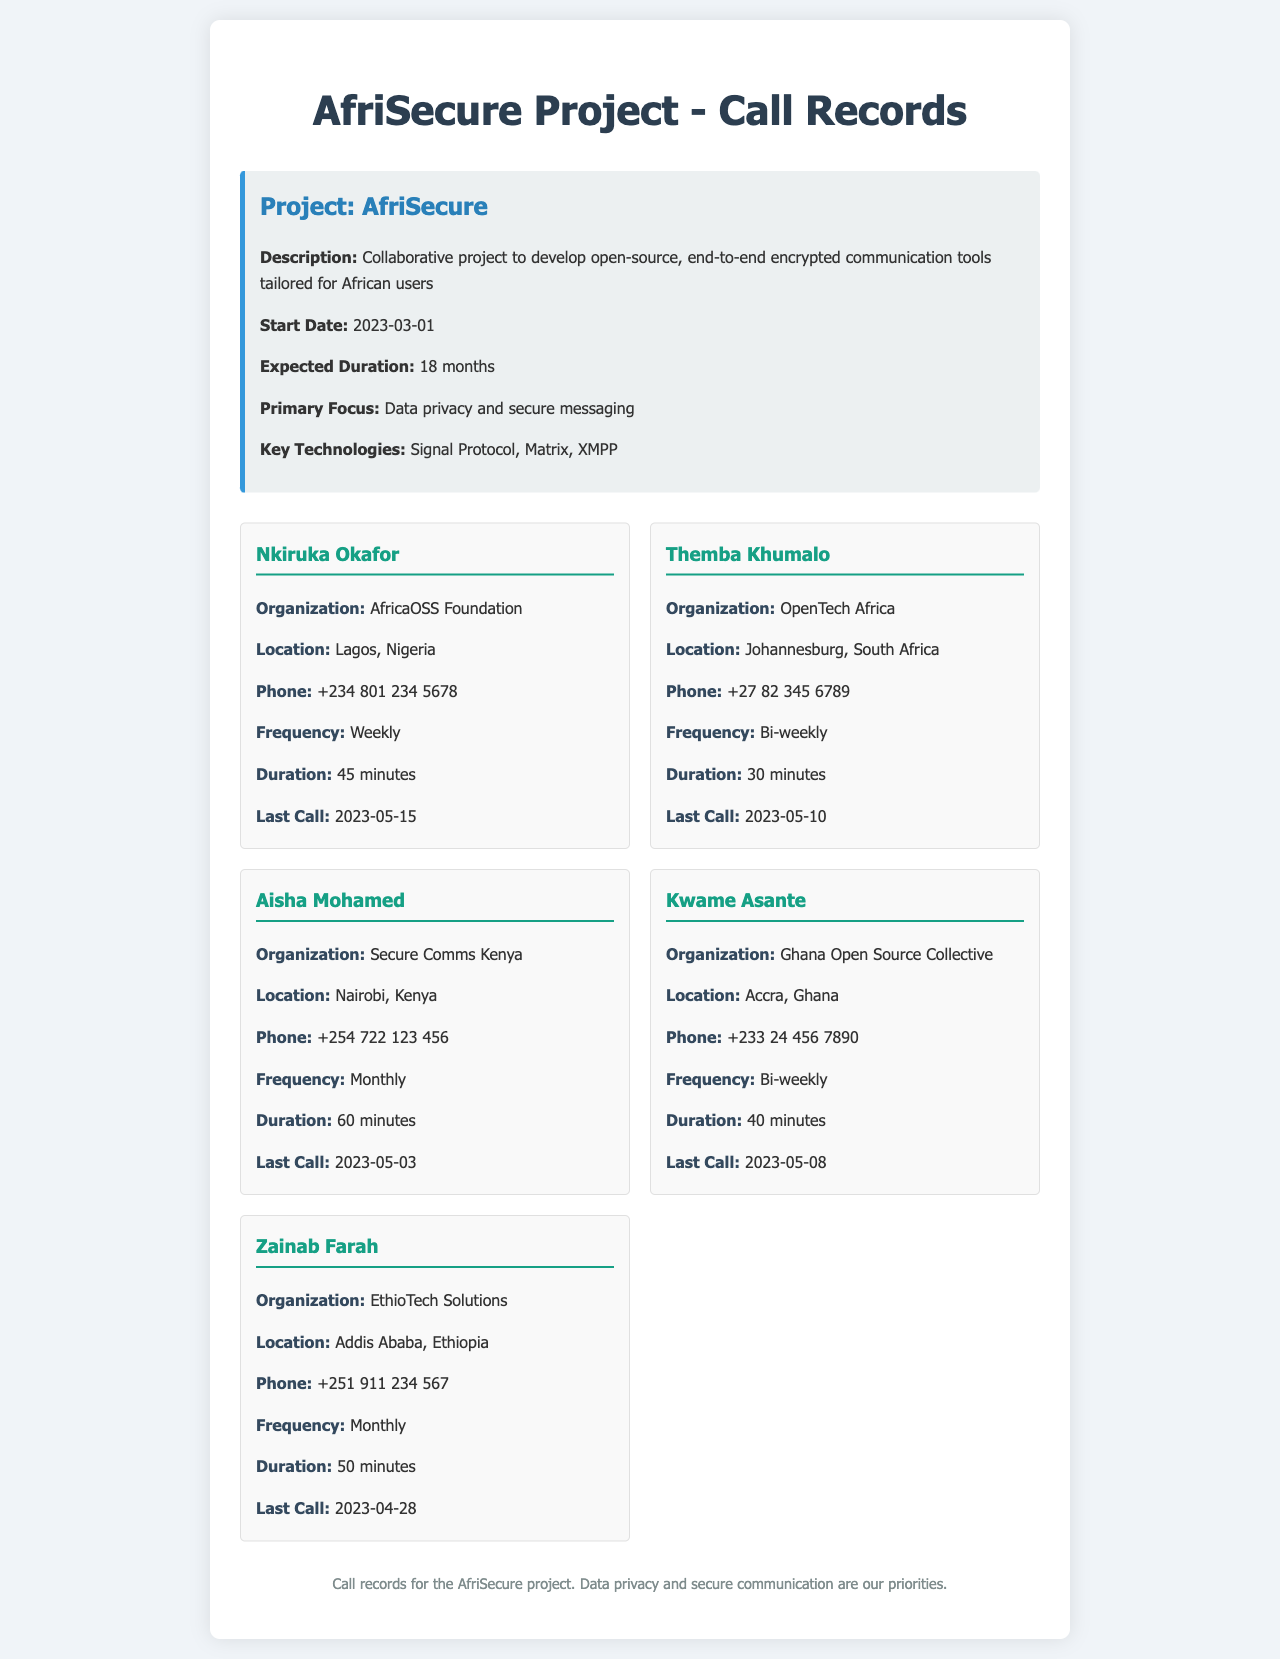What is the name of the project? The name of the project is specified in the document under project details.
Answer: AfriSecure Who is the contact person from the AfricaOSS Foundation? The contact person is listed along with their organization in the call records section.
Answer: Nkiruka Okafor What is the location of Aisha Mohamed? The location of Aisha Mohamed is mentioned in the call records section.
Answer: Nairobi, Kenya How often do the calls with Themba Khumalo occur? The frequency of calls with Themba Khumalo is noted in the document.
Answer: Bi-weekly What was the duration of the last call with Zainab Farah? The duration of the last call is provided in the call records for Zainab Farah.
Answer: 50 minutes Which organization is Kwame Asante associated with? The organization associated with Kwame Asante is detailed in the call records.
Answer: Ghana Open Source Collective When was the last call with Nkiruka Okafor? The last call date is specified for Nkiruka Okafor in the document.
Answer: 2023-05-15 What is the expected duration of the AfriSecure project? The expected duration is mentioned in the project details section of the document.
Answer: 18 months How many minutes was the duration of Aisha Mohamed's calls? The duration is explicitly given for Aisha Mohamed in the call records.
Answer: 60 minutes 